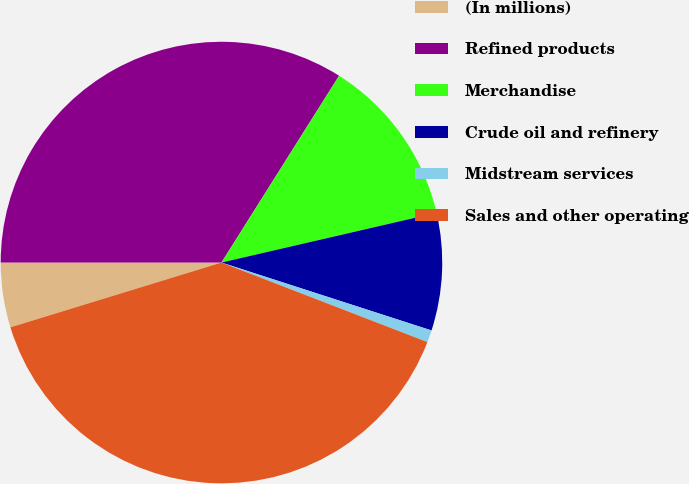Convert chart to OTSL. <chart><loc_0><loc_0><loc_500><loc_500><pie_chart><fcel>(In millions)<fcel>Refined products<fcel>Merchandise<fcel>Crude oil and refinery<fcel>Midstream services<fcel>Sales and other operating<nl><fcel>4.74%<fcel>33.94%<fcel>12.44%<fcel>8.59%<fcel>0.89%<fcel>39.39%<nl></chart> 